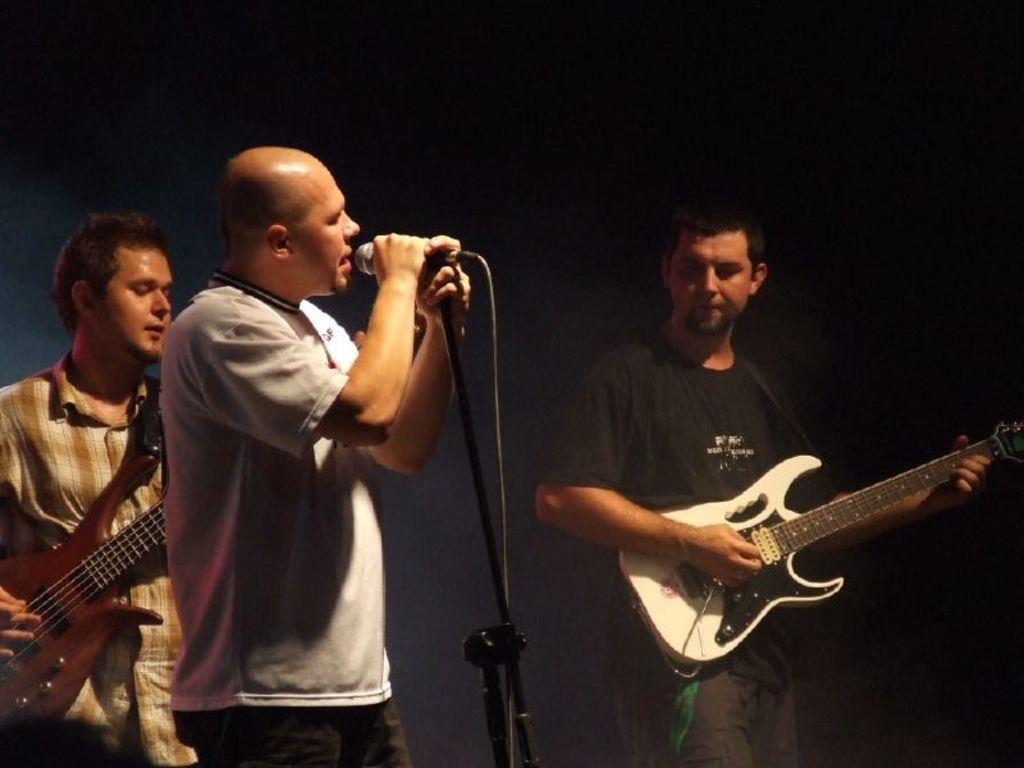Can you describe this image briefly? In this picture we can see three person middle person is singing and on right side person is playing guitar and on left side person is also playing guitar holding in their hands. 